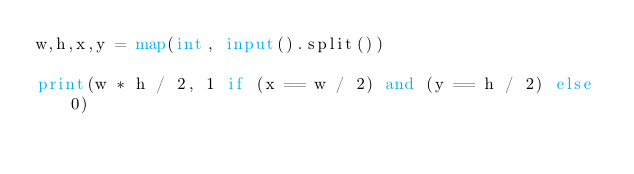<code> <loc_0><loc_0><loc_500><loc_500><_Python_>w,h,x,y = map(int, input().split())

print(w * h / 2, 1 if (x == w / 2) and (y == h / 2) else 0)

</code> 